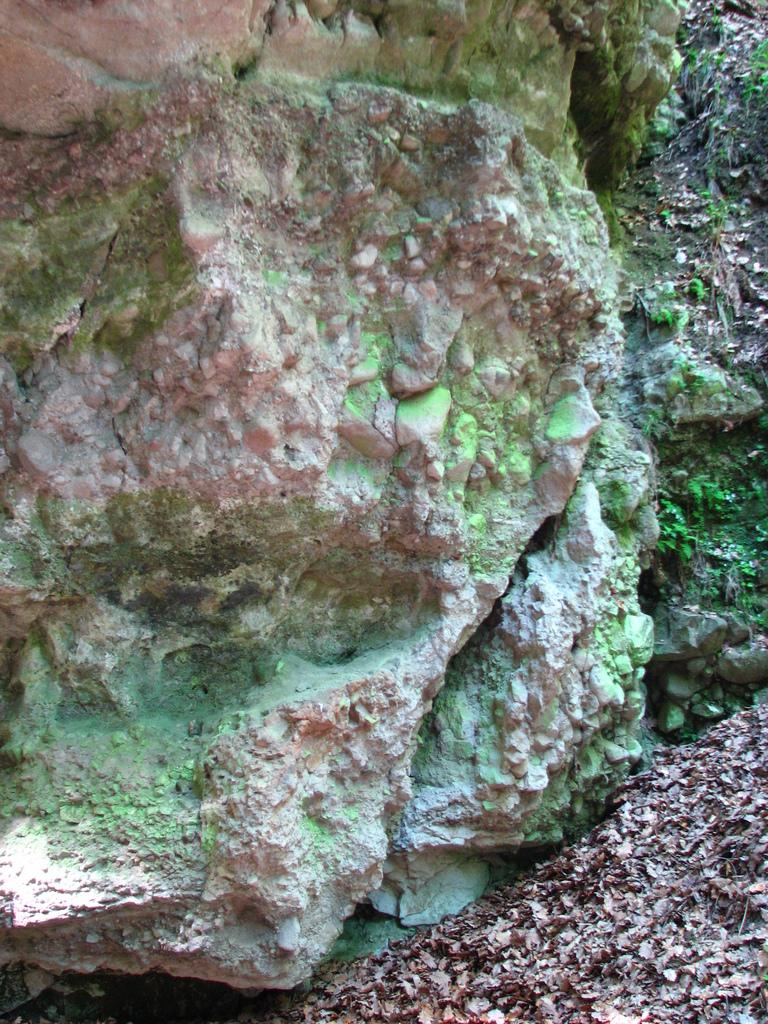What type of natural elements can be seen in the image? There are rocks, leaves, and grass in the image. Can you describe the vegetation present in the image? The image contains leaves and grass. What type of terrain is depicted in the image? The image features rocks, which suggests a rocky terrain. What time of day is it in the image, considering the existence of the afternoon? The image does not provide any information about the time of day, and the concept of the afternoon is not relevant to the image. 